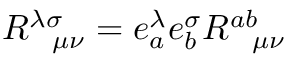Convert formula to latex. <formula><loc_0><loc_0><loc_500><loc_500>R _ { \quad m u \nu } ^ { \lambda \sigma } = e _ { a } ^ { \lambda } e _ { b } ^ { \sigma } R _ { \quad m u \nu } ^ { a b }</formula> 